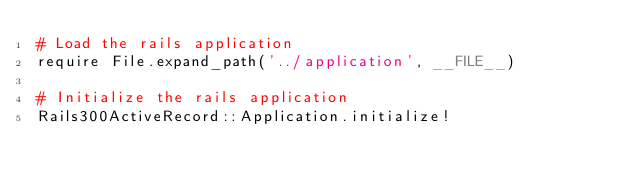<code> <loc_0><loc_0><loc_500><loc_500><_Ruby_># Load the rails application
require File.expand_path('../application', __FILE__)

# Initialize the rails application
Rails300ActiveRecord::Application.initialize!
</code> 